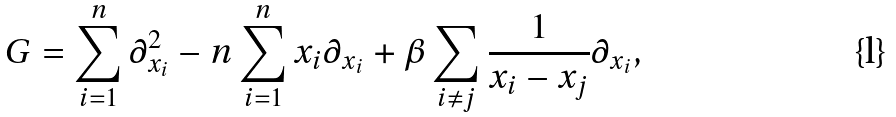<formula> <loc_0><loc_0><loc_500><loc_500>G = \sum _ { i = 1 } ^ { n } \partial ^ { 2 } _ { x _ { i } } - n \sum _ { i = 1 } ^ { n } x _ { i } \partial _ { x _ { i } } + \beta \sum _ { i \neq j } \frac { 1 } { x _ { i } - x _ { j } } \partial _ { x _ { i } } ,</formula> 